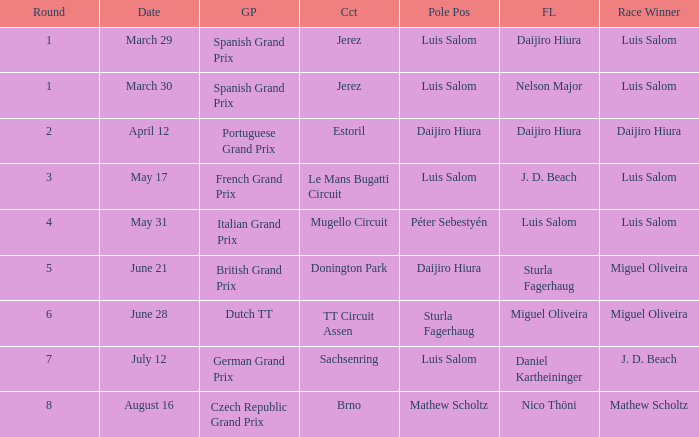Which round 5 Grand Prix had Daijiro Hiura at pole position?  British Grand Prix. Write the full table. {'header': ['Round', 'Date', 'GP', 'Cct', 'Pole Pos', 'FL', 'Race Winner'], 'rows': [['1', 'March 29', 'Spanish Grand Prix', 'Jerez', 'Luis Salom', 'Daijiro Hiura', 'Luis Salom'], ['1', 'March 30', 'Spanish Grand Prix', 'Jerez', 'Luis Salom', 'Nelson Major', 'Luis Salom'], ['2', 'April 12', 'Portuguese Grand Prix', 'Estoril', 'Daijiro Hiura', 'Daijiro Hiura', 'Daijiro Hiura'], ['3', 'May 17', 'French Grand Prix', 'Le Mans Bugatti Circuit', 'Luis Salom', 'J. D. Beach', 'Luis Salom'], ['4', 'May 31', 'Italian Grand Prix', 'Mugello Circuit', 'Péter Sebestyén', 'Luis Salom', 'Luis Salom'], ['5', 'June 21', 'British Grand Prix', 'Donington Park', 'Daijiro Hiura', 'Sturla Fagerhaug', 'Miguel Oliveira'], ['6', 'June 28', 'Dutch TT', 'TT Circuit Assen', 'Sturla Fagerhaug', 'Miguel Oliveira', 'Miguel Oliveira'], ['7', 'July 12', 'German Grand Prix', 'Sachsenring', 'Luis Salom', 'Daniel Kartheininger', 'J. D. Beach'], ['8', 'August 16', 'Czech Republic Grand Prix', 'Brno', 'Mathew Scholtz', 'Nico Thöni', 'Mathew Scholtz']]} 